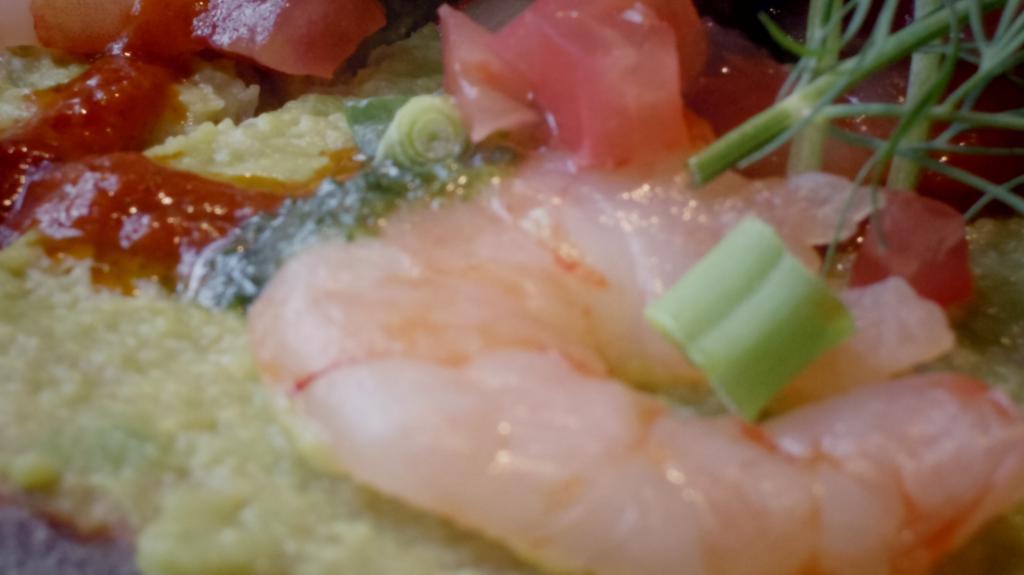Can you describe this image briefly? In this image, we can see a food item. 